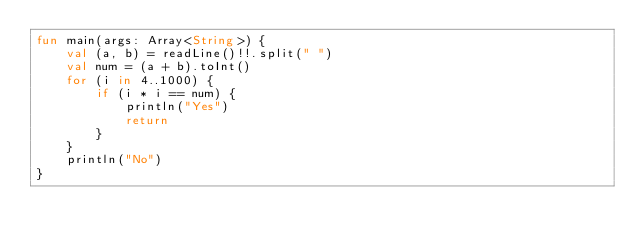Convert code to text. <code><loc_0><loc_0><loc_500><loc_500><_Kotlin_>fun main(args: Array<String>) {
    val (a, b) = readLine()!!.split(" ")
    val num = (a + b).toInt()
    for (i in 4..1000) {
        if (i * i == num) {
            println("Yes")
            return
        }
    }
    println("No")
}
</code> 